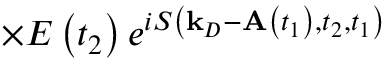Convert formula to latex. <formula><loc_0><loc_0><loc_500><loc_500>\times E \left ( t _ { 2 } \right ) e ^ { i S \left ( k _ { D } - A \left ( t _ { 1 } \right ) , t _ { 2 } , t _ { 1 } \right ) }</formula> 